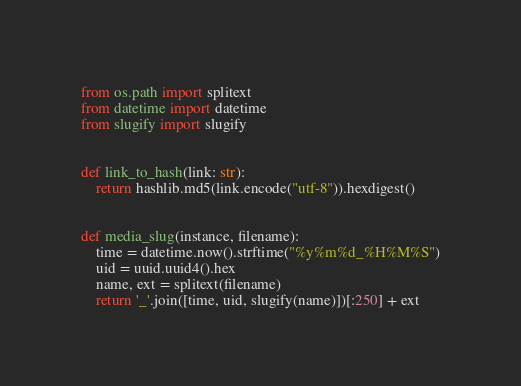<code> <loc_0><loc_0><loc_500><loc_500><_Python_>from os.path import splitext
from datetime import datetime
from slugify import slugify


def link_to_hash(link: str):
    return hashlib.md5(link.encode("utf-8")).hexdigest()


def media_slug(instance, filename):
    time = datetime.now().strftime("%y%m%d_%H%M%S")
    uid = uuid.uuid4().hex
    name, ext = splitext(filename)
    return '_'.join([time, uid, slugify(name)])[:250] + ext
</code> 